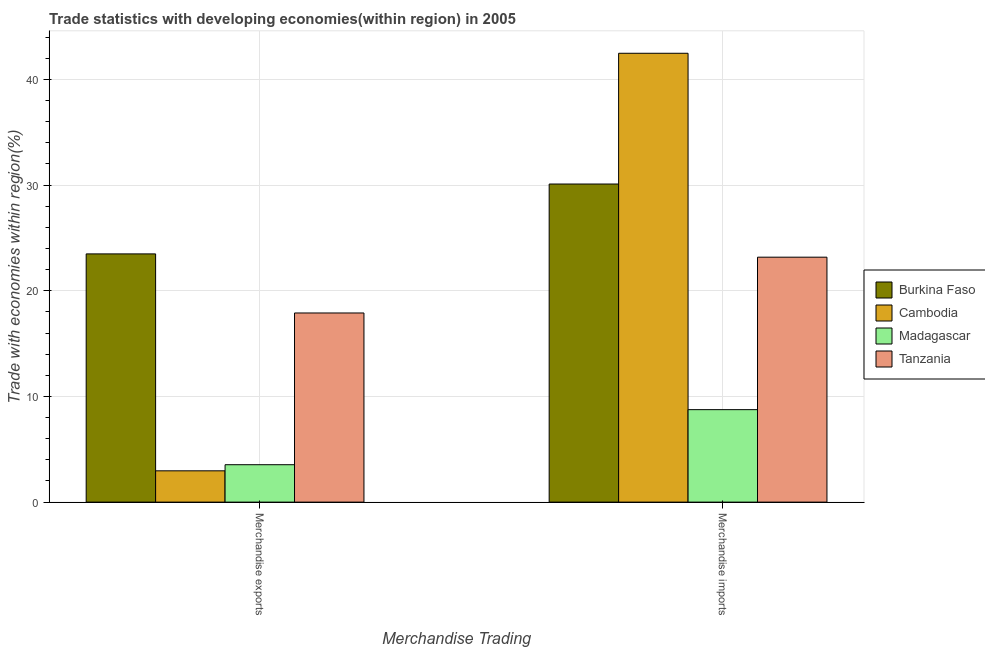How many groups of bars are there?
Provide a short and direct response. 2. Are the number of bars per tick equal to the number of legend labels?
Make the answer very short. Yes. Are the number of bars on each tick of the X-axis equal?
Offer a terse response. Yes. How many bars are there on the 1st tick from the left?
Make the answer very short. 4. What is the merchandise exports in Cambodia?
Give a very brief answer. 2.96. Across all countries, what is the maximum merchandise exports?
Give a very brief answer. 23.48. Across all countries, what is the minimum merchandise exports?
Your response must be concise. 2.96. In which country was the merchandise exports maximum?
Keep it short and to the point. Burkina Faso. In which country was the merchandise imports minimum?
Keep it short and to the point. Madagascar. What is the total merchandise exports in the graph?
Offer a terse response. 47.88. What is the difference between the merchandise exports in Cambodia and that in Madagascar?
Your answer should be very brief. -0.58. What is the difference between the merchandise imports in Madagascar and the merchandise exports in Tanzania?
Make the answer very short. -9.15. What is the average merchandise imports per country?
Your answer should be compact. 26.12. What is the difference between the merchandise imports and merchandise exports in Cambodia?
Provide a succinct answer. 39.51. In how many countries, is the merchandise imports greater than 2 %?
Provide a short and direct response. 4. What is the ratio of the merchandise exports in Cambodia to that in Burkina Faso?
Provide a succinct answer. 0.13. Is the merchandise imports in Madagascar less than that in Tanzania?
Offer a very short reply. Yes. What does the 3rd bar from the left in Merchandise exports represents?
Make the answer very short. Madagascar. What does the 1st bar from the right in Merchandise exports represents?
Your answer should be compact. Tanzania. Are all the bars in the graph horizontal?
Your answer should be compact. No. Are the values on the major ticks of Y-axis written in scientific E-notation?
Provide a short and direct response. No. Where does the legend appear in the graph?
Give a very brief answer. Center right. How many legend labels are there?
Ensure brevity in your answer.  4. What is the title of the graph?
Offer a very short reply. Trade statistics with developing economies(within region) in 2005. What is the label or title of the X-axis?
Your answer should be very brief. Merchandise Trading. What is the label or title of the Y-axis?
Ensure brevity in your answer.  Trade with economies within region(%). What is the Trade with economies within region(%) of Burkina Faso in Merchandise exports?
Give a very brief answer. 23.48. What is the Trade with economies within region(%) of Cambodia in Merchandise exports?
Your response must be concise. 2.96. What is the Trade with economies within region(%) in Madagascar in Merchandise exports?
Provide a short and direct response. 3.54. What is the Trade with economies within region(%) in Tanzania in Merchandise exports?
Offer a terse response. 17.9. What is the Trade with economies within region(%) in Burkina Faso in Merchandise imports?
Offer a very short reply. 30.1. What is the Trade with economies within region(%) of Cambodia in Merchandise imports?
Offer a very short reply. 42.47. What is the Trade with economies within region(%) of Madagascar in Merchandise imports?
Make the answer very short. 8.75. What is the Trade with economies within region(%) in Tanzania in Merchandise imports?
Your answer should be very brief. 23.18. Across all Merchandise Trading, what is the maximum Trade with economies within region(%) in Burkina Faso?
Ensure brevity in your answer.  30.1. Across all Merchandise Trading, what is the maximum Trade with economies within region(%) of Cambodia?
Your answer should be compact. 42.47. Across all Merchandise Trading, what is the maximum Trade with economies within region(%) of Madagascar?
Offer a terse response. 8.75. Across all Merchandise Trading, what is the maximum Trade with economies within region(%) of Tanzania?
Keep it short and to the point. 23.18. Across all Merchandise Trading, what is the minimum Trade with economies within region(%) in Burkina Faso?
Your response must be concise. 23.48. Across all Merchandise Trading, what is the minimum Trade with economies within region(%) of Cambodia?
Offer a very short reply. 2.96. Across all Merchandise Trading, what is the minimum Trade with economies within region(%) in Madagascar?
Your answer should be compact. 3.54. Across all Merchandise Trading, what is the minimum Trade with economies within region(%) in Tanzania?
Provide a short and direct response. 17.9. What is the total Trade with economies within region(%) in Burkina Faso in the graph?
Your answer should be very brief. 53.58. What is the total Trade with economies within region(%) of Cambodia in the graph?
Give a very brief answer. 45.43. What is the total Trade with economies within region(%) of Madagascar in the graph?
Offer a very short reply. 12.29. What is the total Trade with economies within region(%) in Tanzania in the graph?
Keep it short and to the point. 41.07. What is the difference between the Trade with economies within region(%) in Burkina Faso in Merchandise exports and that in Merchandise imports?
Offer a terse response. -6.61. What is the difference between the Trade with economies within region(%) of Cambodia in Merchandise exports and that in Merchandise imports?
Your answer should be compact. -39.51. What is the difference between the Trade with economies within region(%) of Madagascar in Merchandise exports and that in Merchandise imports?
Your answer should be very brief. -5.21. What is the difference between the Trade with economies within region(%) of Tanzania in Merchandise exports and that in Merchandise imports?
Your response must be concise. -5.28. What is the difference between the Trade with economies within region(%) of Burkina Faso in Merchandise exports and the Trade with economies within region(%) of Cambodia in Merchandise imports?
Provide a succinct answer. -18.98. What is the difference between the Trade with economies within region(%) of Burkina Faso in Merchandise exports and the Trade with economies within region(%) of Madagascar in Merchandise imports?
Ensure brevity in your answer.  14.74. What is the difference between the Trade with economies within region(%) of Burkina Faso in Merchandise exports and the Trade with economies within region(%) of Tanzania in Merchandise imports?
Ensure brevity in your answer.  0.31. What is the difference between the Trade with economies within region(%) in Cambodia in Merchandise exports and the Trade with economies within region(%) in Madagascar in Merchandise imports?
Give a very brief answer. -5.79. What is the difference between the Trade with economies within region(%) of Cambodia in Merchandise exports and the Trade with economies within region(%) of Tanzania in Merchandise imports?
Offer a terse response. -20.21. What is the difference between the Trade with economies within region(%) in Madagascar in Merchandise exports and the Trade with economies within region(%) in Tanzania in Merchandise imports?
Your answer should be very brief. -19.64. What is the average Trade with economies within region(%) of Burkina Faso per Merchandise Trading?
Your answer should be compact. 26.79. What is the average Trade with economies within region(%) of Cambodia per Merchandise Trading?
Keep it short and to the point. 22.71. What is the average Trade with economies within region(%) of Madagascar per Merchandise Trading?
Your answer should be compact. 6.14. What is the average Trade with economies within region(%) of Tanzania per Merchandise Trading?
Your response must be concise. 20.54. What is the difference between the Trade with economies within region(%) in Burkina Faso and Trade with economies within region(%) in Cambodia in Merchandise exports?
Give a very brief answer. 20.52. What is the difference between the Trade with economies within region(%) of Burkina Faso and Trade with economies within region(%) of Madagascar in Merchandise exports?
Give a very brief answer. 19.94. What is the difference between the Trade with economies within region(%) in Burkina Faso and Trade with economies within region(%) in Tanzania in Merchandise exports?
Provide a short and direct response. 5.59. What is the difference between the Trade with economies within region(%) of Cambodia and Trade with economies within region(%) of Madagascar in Merchandise exports?
Offer a very short reply. -0.58. What is the difference between the Trade with economies within region(%) of Cambodia and Trade with economies within region(%) of Tanzania in Merchandise exports?
Your answer should be very brief. -14.93. What is the difference between the Trade with economies within region(%) in Madagascar and Trade with economies within region(%) in Tanzania in Merchandise exports?
Provide a short and direct response. -14.36. What is the difference between the Trade with economies within region(%) in Burkina Faso and Trade with economies within region(%) in Cambodia in Merchandise imports?
Offer a terse response. -12.37. What is the difference between the Trade with economies within region(%) of Burkina Faso and Trade with economies within region(%) of Madagascar in Merchandise imports?
Provide a succinct answer. 21.35. What is the difference between the Trade with economies within region(%) of Burkina Faso and Trade with economies within region(%) of Tanzania in Merchandise imports?
Your response must be concise. 6.92. What is the difference between the Trade with economies within region(%) in Cambodia and Trade with economies within region(%) in Madagascar in Merchandise imports?
Ensure brevity in your answer.  33.72. What is the difference between the Trade with economies within region(%) in Cambodia and Trade with economies within region(%) in Tanzania in Merchandise imports?
Provide a succinct answer. 19.29. What is the difference between the Trade with economies within region(%) in Madagascar and Trade with economies within region(%) in Tanzania in Merchandise imports?
Your answer should be very brief. -14.43. What is the ratio of the Trade with economies within region(%) in Burkina Faso in Merchandise exports to that in Merchandise imports?
Provide a short and direct response. 0.78. What is the ratio of the Trade with economies within region(%) in Cambodia in Merchandise exports to that in Merchandise imports?
Make the answer very short. 0.07. What is the ratio of the Trade with economies within region(%) in Madagascar in Merchandise exports to that in Merchandise imports?
Ensure brevity in your answer.  0.4. What is the ratio of the Trade with economies within region(%) of Tanzania in Merchandise exports to that in Merchandise imports?
Your answer should be very brief. 0.77. What is the difference between the highest and the second highest Trade with economies within region(%) of Burkina Faso?
Your answer should be compact. 6.61. What is the difference between the highest and the second highest Trade with economies within region(%) of Cambodia?
Offer a terse response. 39.51. What is the difference between the highest and the second highest Trade with economies within region(%) of Madagascar?
Offer a very short reply. 5.21. What is the difference between the highest and the second highest Trade with economies within region(%) in Tanzania?
Keep it short and to the point. 5.28. What is the difference between the highest and the lowest Trade with economies within region(%) in Burkina Faso?
Your answer should be very brief. 6.61. What is the difference between the highest and the lowest Trade with economies within region(%) in Cambodia?
Provide a succinct answer. 39.51. What is the difference between the highest and the lowest Trade with economies within region(%) of Madagascar?
Offer a terse response. 5.21. What is the difference between the highest and the lowest Trade with economies within region(%) of Tanzania?
Your answer should be very brief. 5.28. 